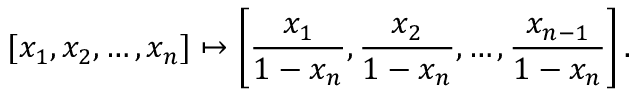<formula> <loc_0><loc_0><loc_500><loc_500>[ x _ { 1 } , x _ { 2 } , \dots , x _ { n } ] \mapsto \left [ { \frac { x _ { 1 } } { 1 - x _ { n } } } , { \frac { x _ { 2 } } { 1 - x _ { n } } } , \dots , { \frac { x _ { n - 1 } } { 1 - x _ { n } } } \right ] .</formula> 